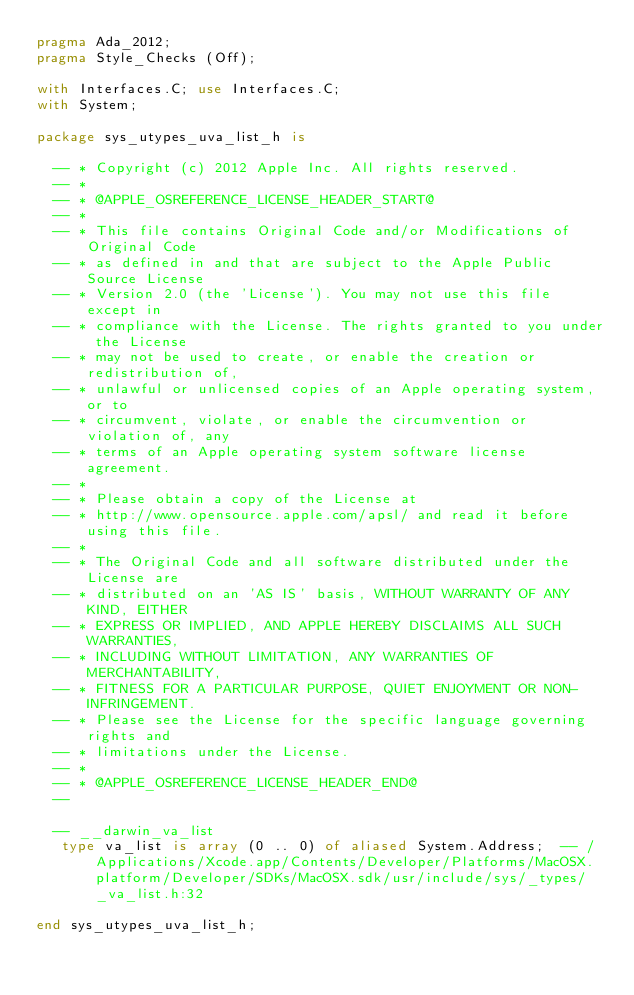<code> <loc_0><loc_0><loc_500><loc_500><_Ada_>pragma Ada_2012;
pragma Style_Checks (Off);

with Interfaces.C; use Interfaces.C;
with System;

package sys_utypes_uva_list_h is

  -- * Copyright (c) 2012 Apple Inc. All rights reserved.
  -- *
  -- * @APPLE_OSREFERENCE_LICENSE_HEADER_START@
  -- *
  -- * This file contains Original Code and/or Modifications of Original Code
  -- * as defined in and that are subject to the Apple Public Source License
  -- * Version 2.0 (the 'License'). You may not use this file except in
  -- * compliance with the License. The rights granted to you under the License
  -- * may not be used to create, or enable the creation or redistribution of,
  -- * unlawful or unlicensed copies of an Apple operating system, or to
  -- * circumvent, violate, or enable the circumvention or violation of, any
  -- * terms of an Apple operating system software license agreement.
  -- *
  -- * Please obtain a copy of the License at
  -- * http://www.opensource.apple.com/apsl/ and read it before using this file.
  -- *
  -- * The Original Code and all software distributed under the License are
  -- * distributed on an 'AS IS' basis, WITHOUT WARRANTY OF ANY KIND, EITHER
  -- * EXPRESS OR IMPLIED, AND APPLE HEREBY DISCLAIMS ALL SUCH WARRANTIES,
  -- * INCLUDING WITHOUT LIMITATION, ANY WARRANTIES OF MERCHANTABILITY,
  -- * FITNESS FOR A PARTICULAR PURPOSE, QUIET ENJOYMENT OR NON-INFRINGEMENT.
  -- * Please see the License for the specific language governing rights and
  -- * limitations under the License.
  -- *
  -- * @APPLE_OSREFERENCE_LICENSE_HEADER_END@
  --  

  -- __darwin_va_list  
   type va_list is array (0 .. 0) of aliased System.Address;  -- /Applications/Xcode.app/Contents/Developer/Platforms/MacOSX.platform/Developer/SDKs/MacOSX.sdk/usr/include/sys/_types/_va_list.h:32

end sys_utypes_uva_list_h;
</code> 